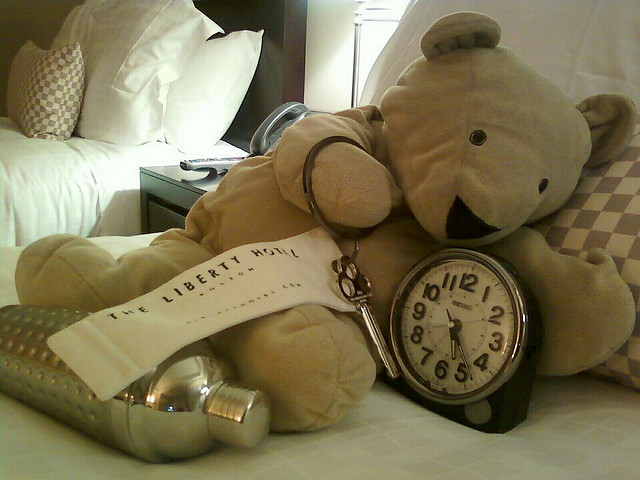Please identify all text content in this image. T H E LIBERTY HOTEL 11 10 9 8 7 6 5 4 3 2 1 12 